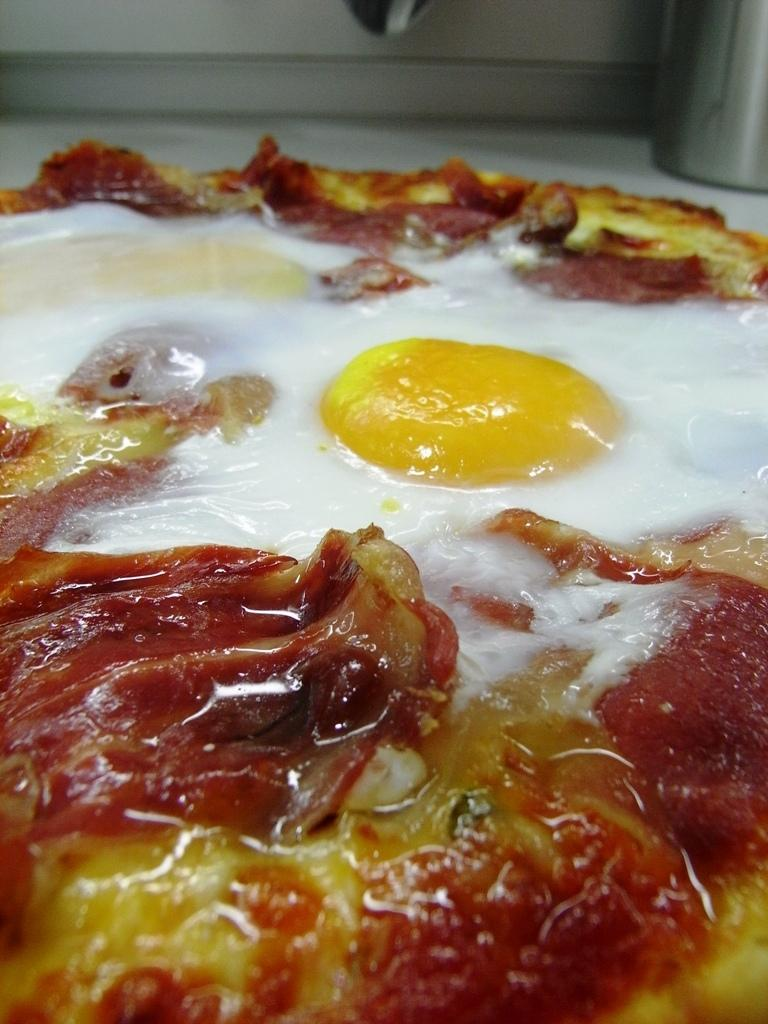What type of food can be seen in the foreground of the image? There is a food item resembling a pizza in the foreground of the image. Can you describe any other objects visible in the image? There is a steel object visible at the top of the image. How many hens are sitting on the pizza in the image? There are no hens present in the image, and the pizza is not being used as a perch for any animals. 